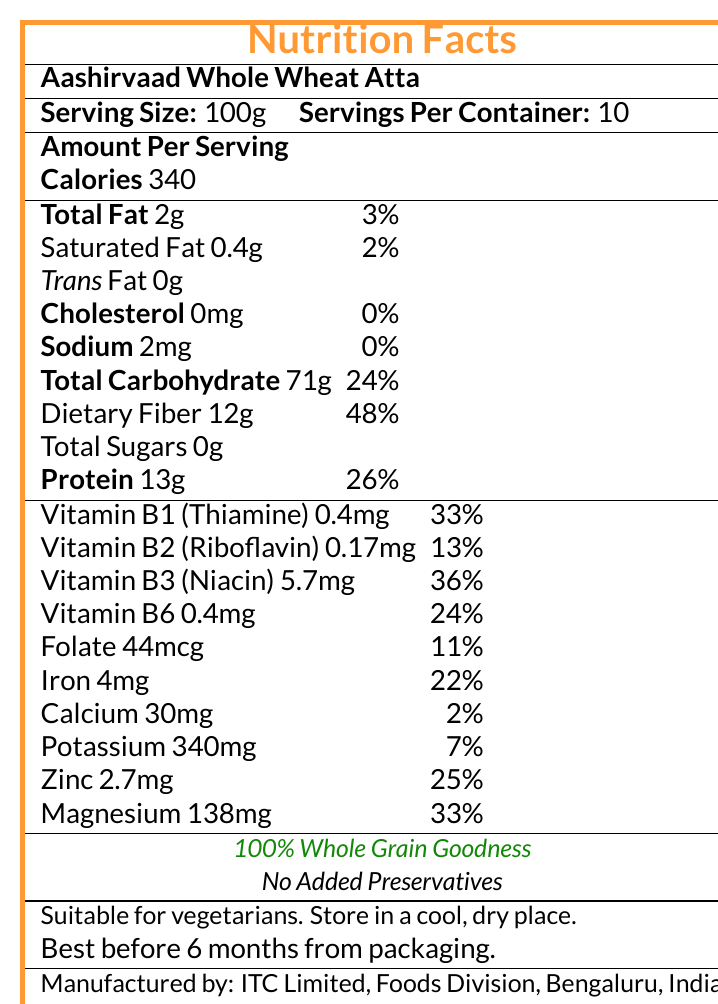what is the serving size for Aashirvaad Whole Wheat Atta? The serving size is mentioned in the text as "Serving Size: 100g".
Answer: 100g How many calories are there per serving? The document states "Calories 340" under the "Amount Per Serving" section.
Answer: 340 How much dietary fiber is in one serving? The "Dietary Fiber" content is listed as 12g in the "Total Carbohydrate" section.
Answer: 12g What percentage of the daily value of total carbohydrates does one serving provide? The document indicates "Total Carbohydrate 71g & 24%" under "Amount Per Serving".
Answer: 24% How much niacin (Vitamin B3) is in one serving? The document lists "Vitamin B3 (Niacin) 5.7mg" under the vitamin section.
Answer: 5.7mg Is the product suitable for vegetarians? The document states "Suitable for vegetarians" in the additional information section.
Answer: Yes What is the recommended storage condition for Aashirvaad Whole Wheat Atta? The storage instruction "Store in a cool, dry place" is mentioned in the additional information section.
Answer: Store in a cool, dry place Which vitamin has the highest percentage of daily value per serving? A. Vitamin B1 (Thiamine) B. Vitamin B2 (Riboflavin) C. Folate D. Vitamin B6 Vitamin B1 (Thiamine) has a daily value of 33%, which is the highest compared to the other listed vitamins.
Answer: A. Vitamin B1 (Thiamine) How much calcium is in one serving? The document states "Calcium 30mg" under the mineral section.
Answer: 30mg How many grams of protein are in one serving? The protein content is listed as "Protein 13g" under "Amount Per Serving".
Answer: 13g Who manufactures Aashirvaad Whole Wheat Atta? The manufacturer information is provided at the end of the document.
Answer: ITC Limited, Foods Division, Bengaluru, India What is the contact number for customer care? The customer care contact number is provided at the end of the document.
Answer: +91 1800 419 2727 Does the product contain any trans fat? The document indicates "Trans Fat 0g".
Answer: No How much iron is in one serving? The iron content is listed as "Iron 4mg" under the mineral section.
Answer: 4mg Which mineral has the highest daily value percentage per serving? A. Potassium B. Zinc C. Magnesium D. Sodium Magnesium has the highest daily value percentage at 33%, as indicated in the document.
Answer: C. Magnesium What is the best before date mentioned for the product? The document specifies "Best before 6 months from packaging."
Answer: Best before 6 months from packaging How many total sugars are there in one serving? The document indicates "Total Sugars 0g".
Answer: 0g Does Aashirvaad Whole Wheat Atta contain any added preservatives? The document mentions "No Added Preservatives" in the additional information section.
Answer: No Describe the overall information provided in the document. The document provides a comprehensive overview of the nutritional content and additional product information for Aashirvaad Whole Wheat Atta.
Answer: The document is a nutrition facts label detailing the nutritional information of Aashirvaad Whole Wheat Atta. It includes serving size, calorie content, amounts and daily value percentages of various nutrients, such as fats, carbohydrates, protein, dietary fiber, vitamins (B1, B2, B3, B6, folate), and minerals (iron, calcium, potassium, zinc, magnesium). It also provides additional information about the product being suitable for vegetarians, storage instructions, manufacturer details, and customer care contact. When was the product manufactured? The document does not provide a manufacturing date, only the best before date relative to the packaging date.
Answer: Not enough information 